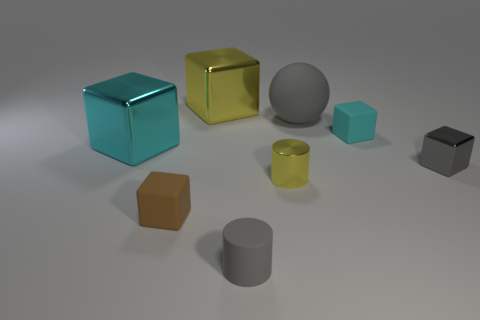There is a large cyan metallic object to the left of the yellow shiny block; does it have the same shape as the yellow shiny thing behind the small yellow object?
Keep it short and to the point. Yes. Are there the same number of cyan metallic things left of the big cyan metallic object and large yellow objects that are to the left of the gray rubber cylinder?
Your response must be concise. No. There is a ball; how many metallic things are in front of it?
Make the answer very short. 3. What number of objects are brown cylinders or gray spheres?
Keep it short and to the point. 1. How many metallic cylinders are the same size as the gray metallic cube?
Provide a succinct answer. 1. What is the shape of the rubber object to the left of the big yellow metallic cube that is to the left of the tiny cyan rubber block?
Give a very brief answer. Cube. Are there fewer gray cubes than small blue rubber cubes?
Your response must be concise. No. The shiny thing behind the big rubber sphere is what color?
Your response must be concise. Yellow. What material is the thing that is both right of the big yellow block and behind the cyan rubber thing?
Make the answer very short. Rubber. There is a gray thing that is the same material as the large gray sphere; what is its shape?
Your answer should be compact. Cylinder. 